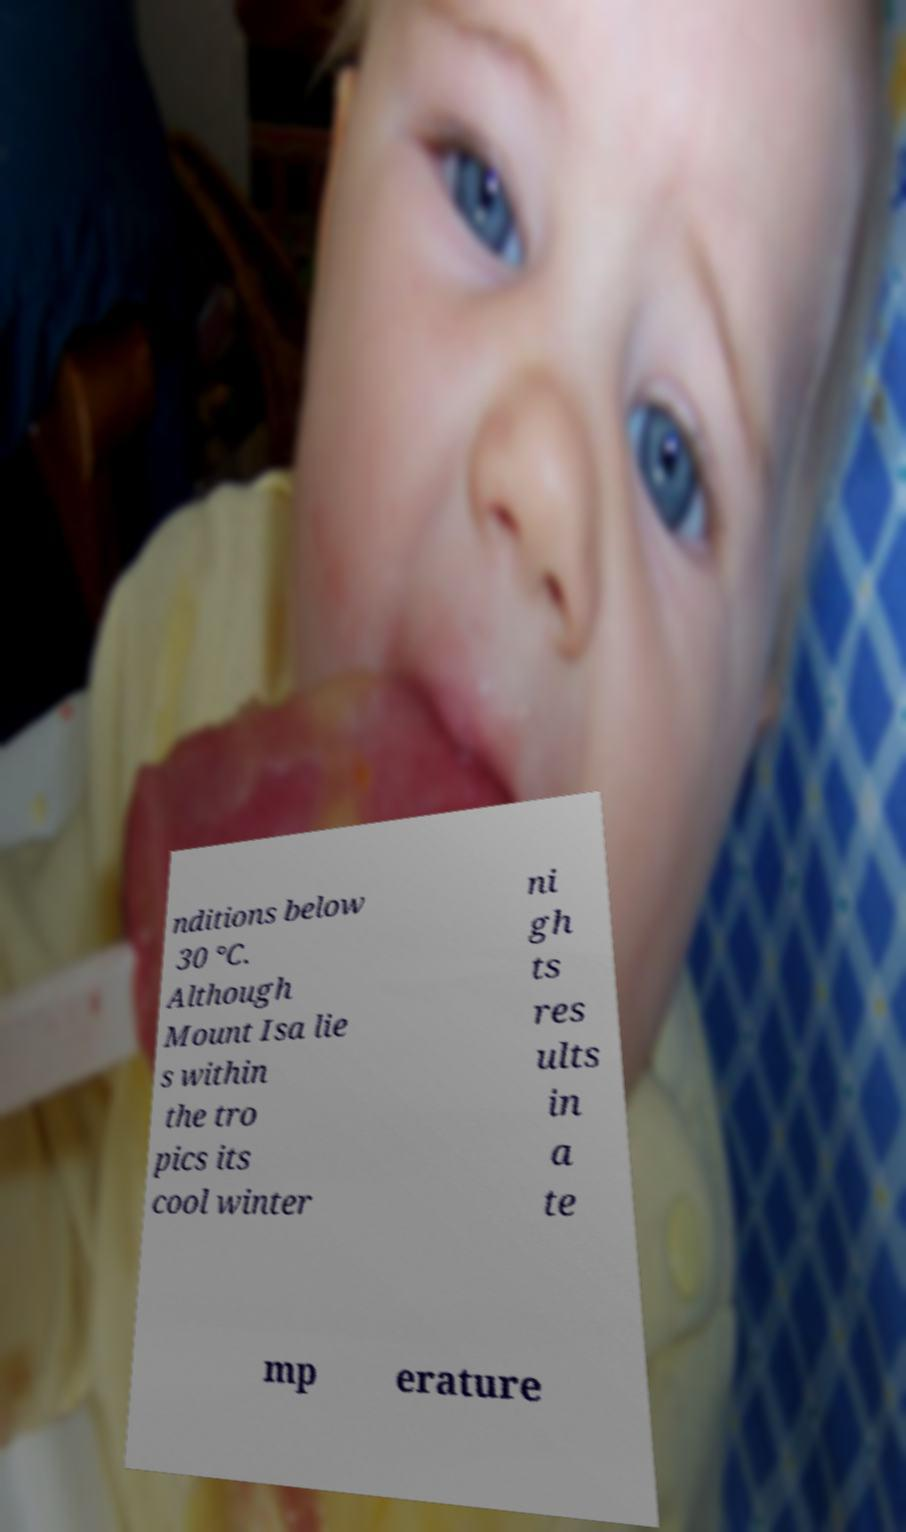Could you assist in decoding the text presented in this image and type it out clearly? nditions below 30 °C. Although Mount Isa lie s within the tro pics its cool winter ni gh ts res ults in a te mp erature 